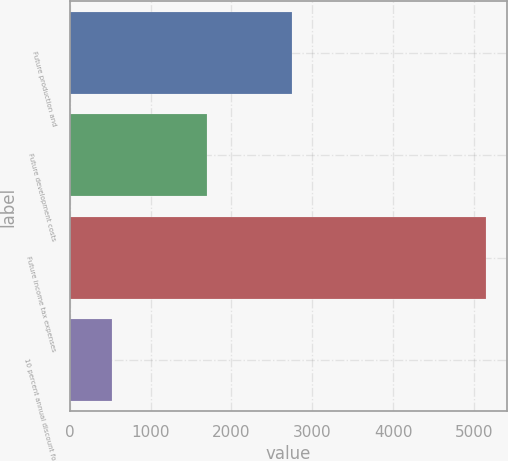Convert chart to OTSL. <chart><loc_0><loc_0><loc_500><loc_500><bar_chart><fcel>Future production and<fcel>Future development costs<fcel>Future income tax expenses<fcel>10 percent annual discount for<nl><fcel>2752<fcel>1702<fcel>5147<fcel>528<nl></chart> 